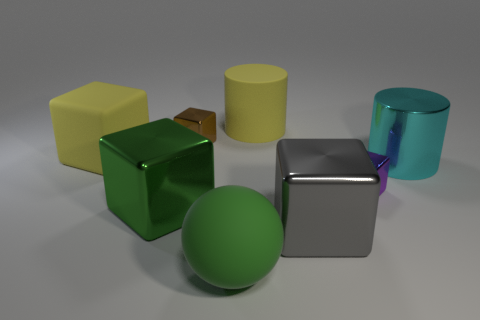The large yellow matte thing that is left of the big yellow object that is to the right of the tiny brown metallic block is what shape?
Keep it short and to the point. Cube. Are there any big yellow objects of the same shape as the cyan object?
Your answer should be compact. Yes. What number of cyan metallic objects are there?
Your answer should be very brief. 1. Do the big cylinder that is in front of the yellow matte cube and the ball have the same material?
Your answer should be compact. No. Is there a gray metal object of the same size as the yellow rubber cube?
Ensure brevity in your answer.  Yes. There is a small brown thing; is it the same shape as the yellow matte object that is right of the green matte sphere?
Offer a terse response. No. There is a large cylinder to the left of the large cylinder in front of the brown thing; is there a green ball that is to the right of it?
Ensure brevity in your answer.  No. How big is the rubber sphere?
Make the answer very short. Large. How many other things are the same color as the matte cube?
Your answer should be very brief. 1. Does the tiny metallic object that is to the right of the gray metallic cube have the same shape as the large gray thing?
Your answer should be very brief. Yes. 